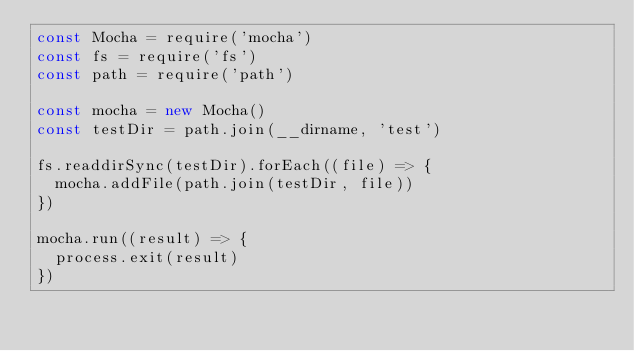<code> <loc_0><loc_0><loc_500><loc_500><_JavaScript_>const Mocha = require('mocha')
const fs = require('fs')
const path = require('path')

const mocha = new Mocha()
const testDir = path.join(__dirname, 'test')

fs.readdirSync(testDir).forEach((file) => {
  mocha.addFile(path.join(testDir, file))
})

mocha.run((result) => {
  process.exit(result)
})
</code> 